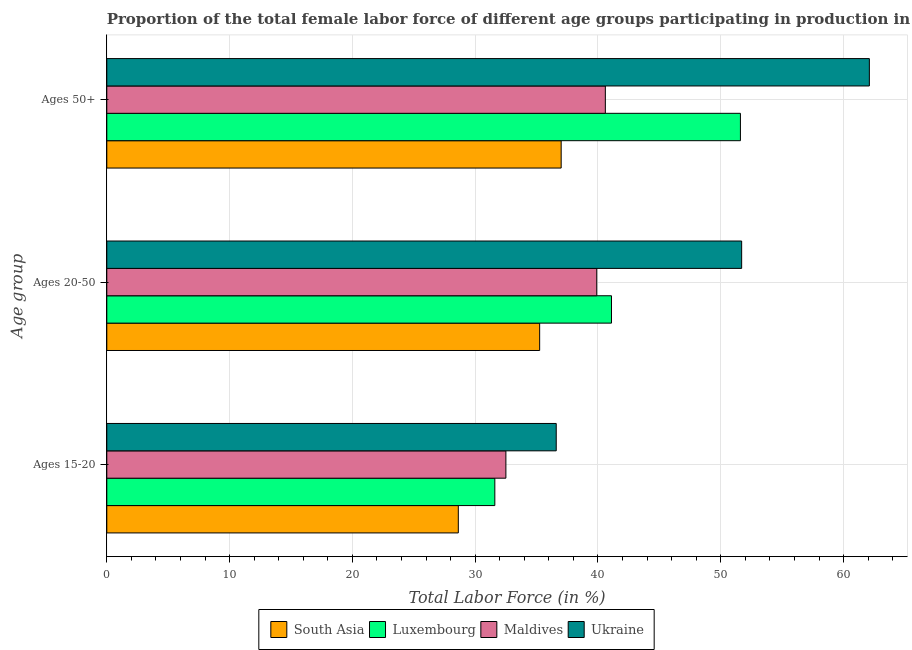How many different coloured bars are there?
Provide a short and direct response. 4. Are the number of bars on each tick of the Y-axis equal?
Keep it short and to the point. Yes. What is the label of the 3rd group of bars from the top?
Keep it short and to the point. Ages 15-20. What is the percentage of female labor force within the age group 15-20 in South Asia?
Offer a terse response. 28.63. Across all countries, what is the maximum percentage of female labor force above age 50?
Your response must be concise. 62.1. Across all countries, what is the minimum percentage of female labor force above age 50?
Your response must be concise. 37. In which country was the percentage of female labor force within the age group 15-20 maximum?
Offer a terse response. Ukraine. What is the total percentage of female labor force above age 50 in the graph?
Provide a succinct answer. 191.3. What is the difference between the percentage of female labor force within the age group 20-50 in Ukraine and that in Maldives?
Keep it short and to the point. 11.8. What is the difference between the percentage of female labor force within the age group 20-50 in Luxembourg and the percentage of female labor force within the age group 15-20 in South Asia?
Keep it short and to the point. 12.47. What is the average percentage of female labor force above age 50 per country?
Ensure brevity in your answer.  47.83. In how many countries, is the percentage of female labor force within the age group 15-20 greater than 42 %?
Keep it short and to the point. 0. What is the ratio of the percentage of female labor force above age 50 in South Asia to that in Luxembourg?
Offer a terse response. 0.72. Is the difference between the percentage of female labor force above age 50 in Luxembourg and Ukraine greater than the difference between the percentage of female labor force within the age group 15-20 in Luxembourg and Ukraine?
Offer a terse response. No. What is the difference between the highest and the second highest percentage of female labor force within the age group 15-20?
Ensure brevity in your answer.  4.1. What is the difference between the highest and the lowest percentage of female labor force within the age group 15-20?
Provide a short and direct response. 7.97. Is the sum of the percentage of female labor force within the age group 15-20 in South Asia and Maldives greater than the maximum percentage of female labor force within the age group 20-50 across all countries?
Your answer should be compact. Yes. What does the 2nd bar from the top in Ages 50+ represents?
Your answer should be very brief. Maldives. How many bars are there?
Give a very brief answer. 12. What is the difference between two consecutive major ticks on the X-axis?
Keep it short and to the point. 10. Are the values on the major ticks of X-axis written in scientific E-notation?
Offer a very short reply. No. Does the graph contain any zero values?
Keep it short and to the point. No. Where does the legend appear in the graph?
Your answer should be very brief. Bottom center. What is the title of the graph?
Offer a terse response. Proportion of the total female labor force of different age groups participating in production in 2001. What is the label or title of the Y-axis?
Provide a succinct answer. Age group. What is the Total Labor Force (in %) of South Asia in Ages 15-20?
Make the answer very short. 28.63. What is the Total Labor Force (in %) of Luxembourg in Ages 15-20?
Your answer should be very brief. 31.6. What is the Total Labor Force (in %) of Maldives in Ages 15-20?
Offer a very short reply. 32.5. What is the Total Labor Force (in %) of Ukraine in Ages 15-20?
Keep it short and to the point. 36.6. What is the Total Labor Force (in %) of South Asia in Ages 20-50?
Offer a very short reply. 35.25. What is the Total Labor Force (in %) in Luxembourg in Ages 20-50?
Your answer should be very brief. 41.1. What is the Total Labor Force (in %) in Maldives in Ages 20-50?
Provide a short and direct response. 39.9. What is the Total Labor Force (in %) in Ukraine in Ages 20-50?
Keep it short and to the point. 51.7. What is the Total Labor Force (in %) in South Asia in Ages 50+?
Offer a terse response. 37. What is the Total Labor Force (in %) in Luxembourg in Ages 50+?
Your response must be concise. 51.6. What is the Total Labor Force (in %) in Maldives in Ages 50+?
Your answer should be compact. 40.6. What is the Total Labor Force (in %) in Ukraine in Ages 50+?
Your answer should be compact. 62.1. Across all Age group, what is the maximum Total Labor Force (in %) of South Asia?
Provide a short and direct response. 37. Across all Age group, what is the maximum Total Labor Force (in %) in Luxembourg?
Keep it short and to the point. 51.6. Across all Age group, what is the maximum Total Labor Force (in %) of Maldives?
Offer a very short reply. 40.6. Across all Age group, what is the maximum Total Labor Force (in %) in Ukraine?
Your answer should be compact. 62.1. Across all Age group, what is the minimum Total Labor Force (in %) in South Asia?
Ensure brevity in your answer.  28.63. Across all Age group, what is the minimum Total Labor Force (in %) of Luxembourg?
Ensure brevity in your answer.  31.6. Across all Age group, what is the minimum Total Labor Force (in %) of Maldives?
Keep it short and to the point. 32.5. Across all Age group, what is the minimum Total Labor Force (in %) in Ukraine?
Offer a terse response. 36.6. What is the total Total Labor Force (in %) of South Asia in the graph?
Ensure brevity in your answer.  100.88. What is the total Total Labor Force (in %) of Luxembourg in the graph?
Provide a short and direct response. 124.3. What is the total Total Labor Force (in %) of Maldives in the graph?
Provide a succinct answer. 113. What is the total Total Labor Force (in %) in Ukraine in the graph?
Provide a succinct answer. 150.4. What is the difference between the Total Labor Force (in %) of South Asia in Ages 15-20 and that in Ages 20-50?
Ensure brevity in your answer.  -6.62. What is the difference between the Total Labor Force (in %) in Ukraine in Ages 15-20 and that in Ages 20-50?
Offer a very short reply. -15.1. What is the difference between the Total Labor Force (in %) in South Asia in Ages 15-20 and that in Ages 50+?
Your response must be concise. -8.38. What is the difference between the Total Labor Force (in %) of Luxembourg in Ages 15-20 and that in Ages 50+?
Your response must be concise. -20. What is the difference between the Total Labor Force (in %) of Ukraine in Ages 15-20 and that in Ages 50+?
Keep it short and to the point. -25.5. What is the difference between the Total Labor Force (in %) of South Asia in Ages 20-50 and that in Ages 50+?
Make the answer very short. -1.75. What is the difference between the Total Labor Force (in %) in South Asia in Ages 15-20 and the Total Labor Force (in %) in Luxembourg in Ages 20-50?
Your response must be concise. -12.47. What is the difference between the Total Labor Force (in %) of South Asia in Ages 15-20 and the Total Labor Force (in %) of Maldives in Ages 20-50?
Provide a succinct answer. -11.27. What is the difference between the Total Labor Force (in %) in South Asia in Ages 15-20 and the Total Labor Force (in %) in Ukraine in Ages 20-50?
Your answer should be very brief. -23.07. What is the difference between the Total Labor Force (in %) of Luxembourg in Ages 15-20 and the Total Labor Force (in %) of Maldives in Ages 20-50?
Your answer should be compact. -8.3. What is the difference between the Total Labor Force (in %) of Luxembourg in Ages 15-20 and the Total Labor Force (in %) of Ukraine in Ages 20-50?
Ensure brevity in your answer.  -20.1. What is the difference between the Total Labor Force (in %) of Maldives in Ages 15-20 and the Total Labor Force (in %) of Ukraine in Ages 20-50?
Give a very brief answer. -19.2. What is the difference between the Total Labor Force (in %) of South Asia in Ages 15-20 and the Total Labor Force (in %) of Luxembourg in Ages 50+?
Provide a succinct answer. -22.97. What is the difference between the Total Labor Force (in %) of South Asia in Ages 15-20 and the Total Labor Force (in %) of Maldives in Ages 50+?
Offer a terse response. -11.97. What is the difference between the Total Labor Force (in %) in South Asia in Ages 15-20 and the Total Labor Force (in %) in Ukraine in Ages 50+?
Make the answer very short. -33.47. What is the difference between the Total Labor Force (in %) of Luxembourg in Ages 15-20 and the Total Labor Force (in %) of Ukraine in Ages 50+?
Your answer should be very brief. -30.5. What is the difference between the Total Labor Force (in %) in Maldives in Ages 15-20 and the Total Labor Force (in %) in Ukraine in Ages 50+?
Offer a terse response. -29.6. What is the difference between the Total Labor Force (in %) in South Asia in Ages 20-50 and the Total Labor Force (in %) in Luxembourg in Ages 50+?
Give a very brief answer. -16.35. What is the difference between the Total Labor Force (in %) of South Asia in Ages 20-50 and the Total Labor Force (in %) of Maldives in Ages 50+?
Offer a very short reply. -5.35. What is the difference between the Total Labor Force (in %) in South Asia in Ages 20-50 and the Total Labor Force (in %) in Ukraine in Ages 50+?
Your answer should be very brief. -26.85. What is the difference between the Total Labor Force (in %) in Luxembourg in Ages 20-50 and the Total Labor Force (in %) in Maldives in Ages 50+?
Your answer should be compact. 0.5. What is the difference between the Total Labor Force (in %) of Maldives in Ages 20-50 and the Total Labor Force (in %) of Ukraine in Ages 50+?
Keep it short and to the point. -22.2. What is the average Total Labor Force (in %) in South Asia per Age group?
Offer a very short reply. 33.63. What is the average Total Labor Force (in %) of Luxembourg per Age group?
Ensure brevity in your answer.  41.43. What is the average Total Labor Force (in %) in Maldives per Age group?
Keep it short and to the point. 37.67. What is the average Total Labor Force (in %) in Ukraine per Age group?
Give a very brief answer. 50.13. What is the difference between the Total Labor Force (in %) of South Asia and Total Labor Force (in %) of Luxembourg in Ages 15-20?
Provide a succinct answer. -2.97. What is the difference between the Total Labor Force (in %) of South Asia and Total Labor Force (in %) of Maldives in Ages 15-20?
Offer a terse response. -3.87. What is the difference between the Total Labor Force (in %) of South Asia and Total Labor Force (in %) of Ukraine in Ages 15-20?
Keep it short and to the point. -7.97. What is the difference between the Total Labor Force (in %) in Luxembourg and Total Labor Force (in %) in Maldives in Ages 15-20?
Your answer should be very brief. -0.9. What is the difference between the Total Labor Force (in %) in Luxembourg and Total Labor Force (in %) in Ukraine in Ages 15-20?
Keep it short and to the point. -5. What is the difference between the Total Labor Force (in %) in Maldives and Total Labor Force (in %) in Ukraine in Ages 15-20?
Offer a very short reply. -4.1. What is the difference between the Total Labor Force (in %) of South Asia and Total Labor Force (in %) of Luxembourg in Ages 20-50?
Your answer should be compact. -5.85. What is the difference between the Total Labor Force (in %) in South Asia and Total Labor Force (in %) in Maldives in Ages 20-50?
Offer a very short reply. -4.65. What is the difference between the Total Labor Force (in %) in South Asia and Total Labor Force (in %) in Ukraine in Ages 20-50?
Offer a very short reply. -16.45. What is the difference between the Total Labor Force (in %) in Luxembourg and Total Labor Force (in %) in Maldives in Ages 20-50?
Provide a succinct answer. 1.2. What is the difference between the Total Labor Force (in %) of Luxembourg and Total Labor Force (in %) of Ukraine in Ages 20-50?
Ensure brevity in your answer.  -10.6. What is the difference between the Total Labor Force (in %) of Maldives and Total Labor Force (in %) of Ukraine in Ages 20-50?
Keep it short and to the point. -11.8. What is the difference between the Total Labor Force (in %) in South Asia and Total Labor Force (in %) in Luxembourg in Ages 50+?
Provide a short and direct response. -14.6. What is the difference between the Total Labor Force (in %) of South Asia and Total Labor Force (in %) of Maldives in Ages 50+?
Your answer should be compact. -3.6. What is the difference between the Total Labor Force (in %) of South Asia and Total Labor Force (in %) of Ukraine in Ages 50+?
Provide a short and direct response. -25.1. What is the difference between the Total Labor Force (in %) in Luxembourg and Total Labor Force (in %) in Maldives in Ages 50+?
Offer a very short reply. 11. What is the difference between the Total Labor Force (in %) in Maldives and Total Labor Force (in %) in Ukraine in Ages 50+?
Your answer should be very brief. -21.5. What is the ratio of the Total Labor Force (in %) of South Asia in Ages 15-20 to that in Ages 20-50?
Your response must be concise. 0.81. What is the ratio of the Total Labor Force (in %) in Luxembourg in Ages 15-20 to that in Ages 20-50?
Provide a short and direct response. 0.77. What is the ratio of the Total Labor Force (in %) of Maldives in Ages 15-20 to that in Ages 20-50?
Your answer should be compact. 0.81. What is the ratio of the Total Labor Force (in %) of Ukraine in Ages 15-20 to that in Ages 20-50?
Keep it short and to the point. 0.71. What is the ratio of the Total Labor Force (in %) in South Asia in Ages 15-20 to that in Ages 50+?
Your answer should be very brief. 0.77. What is the ratio of the Total Labor Force (in %) in Luxembourg in Ages 15-20 to that in Ages 50+?
Give a very brief answer. 0.61. What is the ratio of the Total Labor Force (in %) in Maldives in Ages 15-20 to that in Ages 50+?
Provide a succinct answer. 0.8. What is the ratio of the Total Labor Force (in %) in Ukraine in Ages 15-20 to that in Ages 50+?
Your response must be concise. 0.59. What is the ratio of the Total Labor Force (in %) in South Asia in Ages 20-50 to that in Ages 50+?
Your answer should be very brief. 0.95. What is the ratio of the Total Labor Force (in %) in Luxembourg in Ages 20-50 to that in Ages 50+?
Make the answer very short. 0.8. What is the ratio of the Total Labor Force (in %) of Maldives in Ages 20-50 to that in Ages 50+?
Keep it short and to the point. 0.98. What is the ratio of the Total Labor Force (in %) in Ukraine in Ages 20-50 to that in Ages 50+?
Ensure brevity in your answer.  0.83. What is the difference between the highest and the second highest Total Labor Force (in %) in South Asia?
Provide a short and direct response. 1.75. What is the difference between the highest and the second highest Total Labor Force (in %) in Luxembourg?
Your answer should be compact. 10.5. What is the difference between the highest and the second highest Total Labor Force (in %) of Ukraine?
Your answer should be compact. 10.4. What is the difference between the highest and the lowest Total Labor Force (in %) of South Asia?
Your response must be concise. 8.38. What is the difference between the highest and the lowest Total Labor Force (in %) in Luxembourg?
Your answer should be compact. 20. What is the difference between the highest and the lowest Total Labor Force (in %) of Maldives?
Keep it short and to the point. 8.1. 